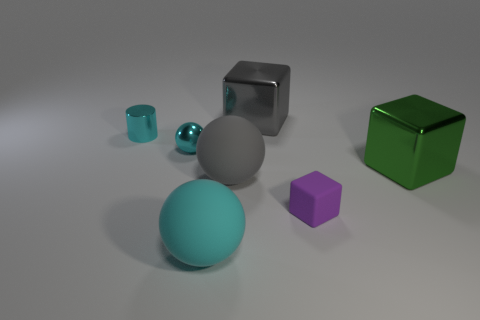Is the number of cyan metal cylinders that are behind the cyan metal ball greater than the number of purple matte cubes that are behind the tiny matte block?
Offer a very short reply. Yes. There is a metal block that is the same size as the gray shiny thing; what is its color?
Your answer should be very brief. Green. Is there a big matte cylinder that has the same color as the small shiny ball?
Provide a succinct answer. No. There is a large thing that is on the right side of the purple matte object; is its color the same as the rubber object that is to the right of the big gray rubber sphere?
Your response must be concise. No. There is a large cube that is left of the matte cube; what material is it?
Your answer should be compact. Metal. What is the color of the tiny ball that is the same material as the big green block?
Offer a terse response. Cyan. What number of green balls are the same size as the cylinder?
Give a very brief answer. 0. There is a shiny cube that is behind the cyan shiny sphere; is its size the same as the tiny purple cube?
Your answer should be compact. No. There is a metallic thing that is on the right side of the big gray ball and behind the tiny cyan metal sphere; what shape is it?
Your answer should be compact. Cube. Are there any cyan metal spheres in front of the cyan rubber object?
Your answer should be very brief. No. 